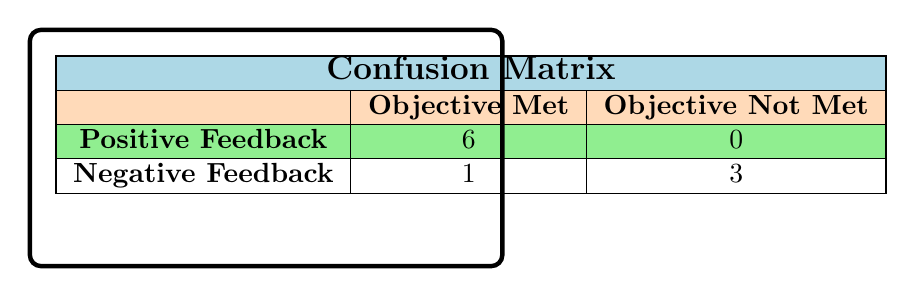What is the total count of events where objectives were met with positive feedback? From the table, we see that there are 6 instances where feedback was positive, and they all fall under "Objective Met." Thus, the total count of events where objectives were met with positive feedback is 6.
Answer: 6 How many events did not meet their objectives and received negative feedback? The table indicates 1 event with negative feedback that also did not meet objectives ("Fundraising Gala"). There are 3 more events where objectives were not met, but they received fair or poor feedback. Hence, the only event that fits both criteria is 1.
Answer: 1 What is the total number of events recorded in the matrix? By summing the cells in the matrix: 6 (positive feedback, objective met) + 0 (negative feedback, objective met) + 1 (positive feedback, objective not met) + 3 (negative feedback, objective not met) gives us a total of 10 events.
Answer: 10 Is there any event with positive feedback that did not meet objectives? According to the table, all events receiving positive feedback have also met their objectives. Therefore, the answer is no, there are no events with positive feedback that did not meet objectives.
Answer: No What is the ratio of events with negative feedback to those with objectives met? From the table, there is 1 event with negative feedback and 6 events with objectives met. To find the ratio, we put these numbers together: 1 (negative feedback) : 6 (objectives met), which simplifies to 1:6.
Answer: 1:6 How many events received poor feedback and did not meet objectives? From the information in the table, there are 3 events categorized under negative feedback that did not meet objectives. Given that one of these is "Fundraising Gala" and the other two have poor ratings, we confirm that 3 total events in this group fit this category.
Answer: 3 Which category has the highest number of events: positive feedback or negative feedback? The table shows 6 events under positive feedback and 4 under negative feedback (1 positive, 3 negative). Therefore, the positive feedback category has more events, totaling 6, compared to negative feedback, which totals 4.
Answer: Positive feedback What is the difference in the number of events between positive feedback and those that did not meet objectives? Analyzing the counts, there are 6 positive feedback events and 4 events that did not meet their objectives (1 positive, 3 negative). The difference is 6 - 4 = 2, meaning there are 2 more positive feedback events than those that did not meet objectives.
Answer: 2 